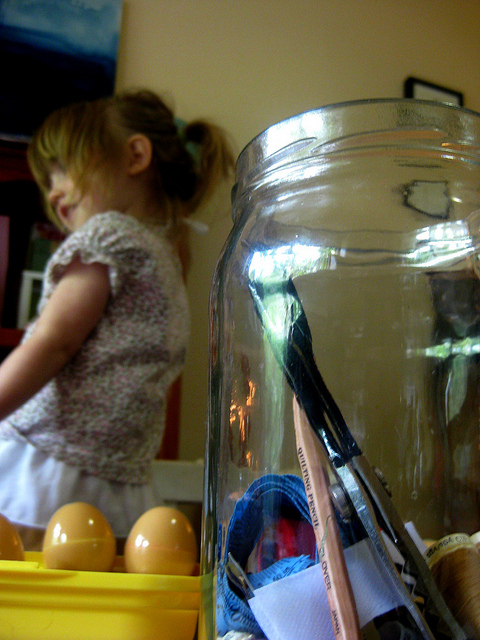Read all the text in this image. OVEN 